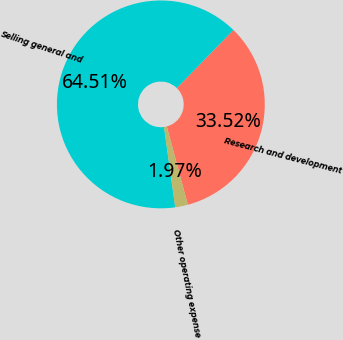Convert chart. <chart><loc_0><loc_0><loc_500><loc_500><pie_chart><fcel>Research and development<fcel>Selling general and<fcel>Other operating expense<nl><fcel>33.52%<fcel>64.51%<fcel>1.97%<nl></chart> 